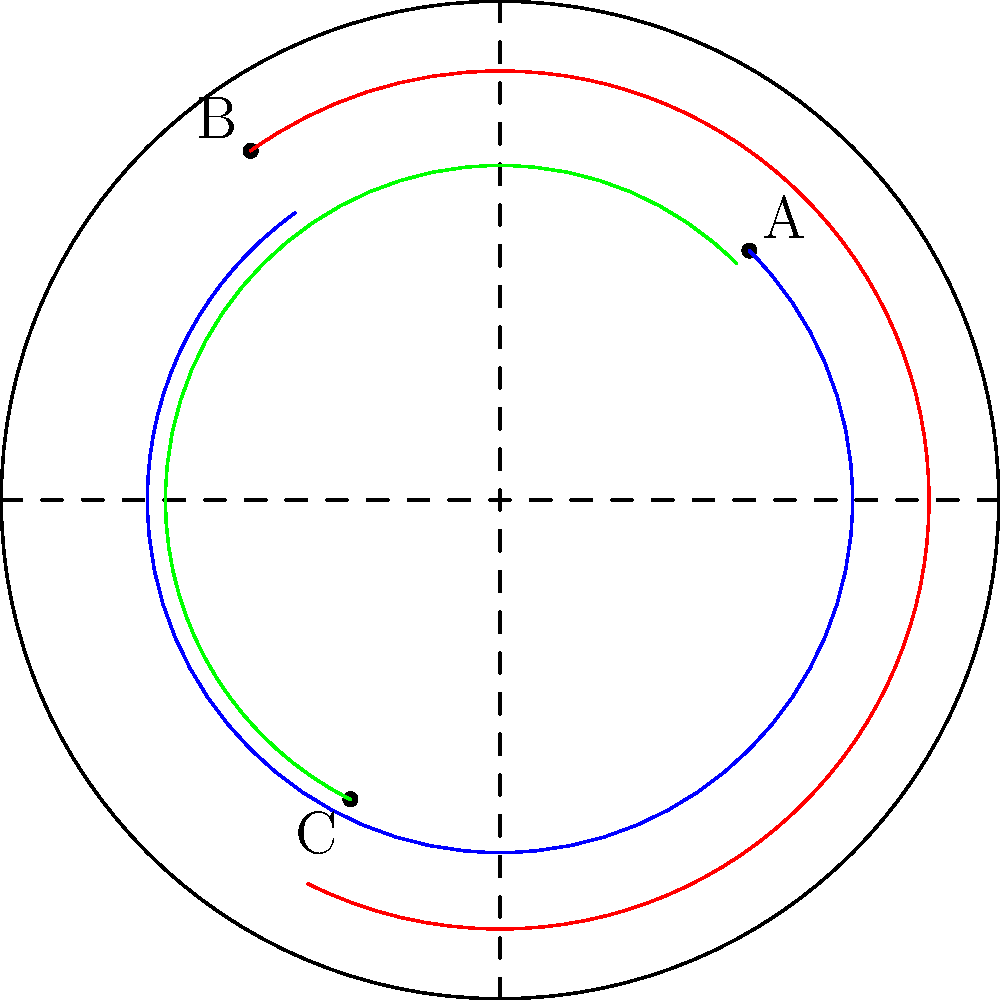In the Poincaré disk model of hyperbolic geometry shown above, three points A, B, and C are connected by hyperbolic lines (represented by circular arcs). What is the sum of the interior angles of the hyperbolic triangle ABC? To answer this question, we need to understand the properties of hyperbolic geometry in the Poincaré disk model:

1. In Euclidean geometry, the sum of interior angles of a triangle is always 180°.

2. In hyperbolic geometry, the sum of interior angles of a triangle is always less than 180°.

3. The Poincaré disk model represents the entire hyperbolic plane as the interior of a unit circle.

4. Straight lines in hyperbolic space are represented by arcs of circles that intersect the boundary circle at right angles.

5. Angles in the Poincaré disk model are measured as the Euclidean angles between the tangent lines to the arcs at their intersection points.

6. As points get closer to the boundary of the disk, the hyperbolic distance between them increases, causing the interior angles of triangles to appear smaller in the Euclidean sense.

7. The further the vertices of a hyperbolic triangle are from the center of the disk, the smaller the sum of its interior angles will be.

In the given diagram:
- The triangle ABC has vertices relatively close to the boundary of the disk.
- This positioning suggests that the sum of interior angles will be significantly less than 180°.

While we cannot calculate the exact sum without more precise measurements, we can confidently state that the sum of interior angles of the hyperbolic triangle ABC is less than 180°.

This property is a fundamental characteristic of hyperbolic geometry and distinguishes it from Euclidean geometry.
Answer: Less than 180° 